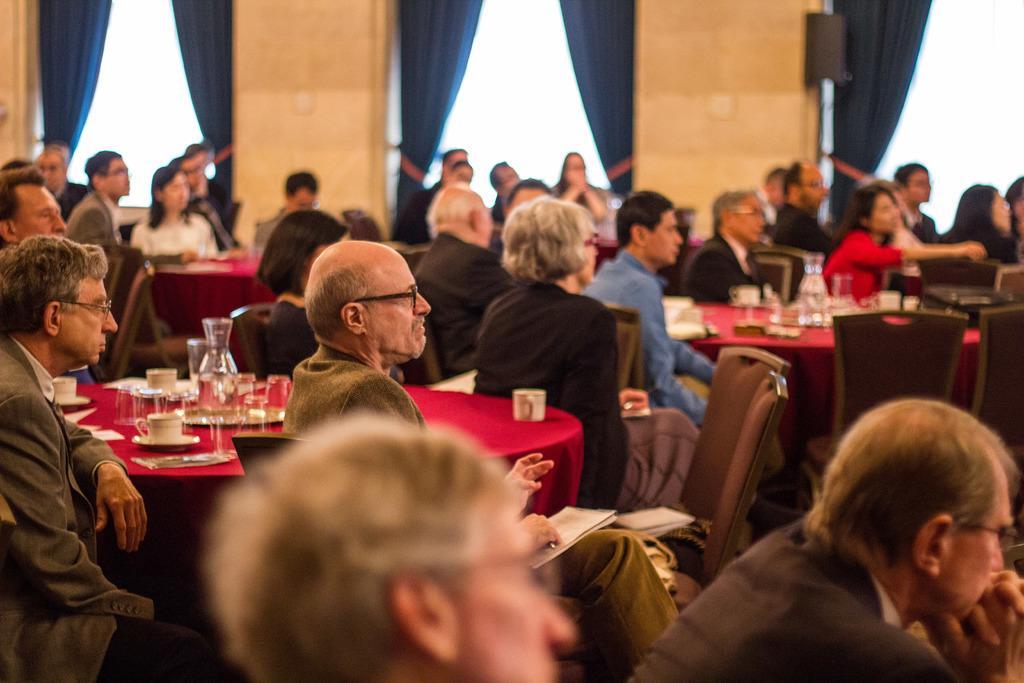How would you summarize this image in a sentence or two? In this picture we can group of people are sitting in the hall watching straight. On the red table we have water glass and tea cup, Beside the table a man wearing black coat and pant is sitting and watching straight. Behind there is a brown color wall and blue big curtain 